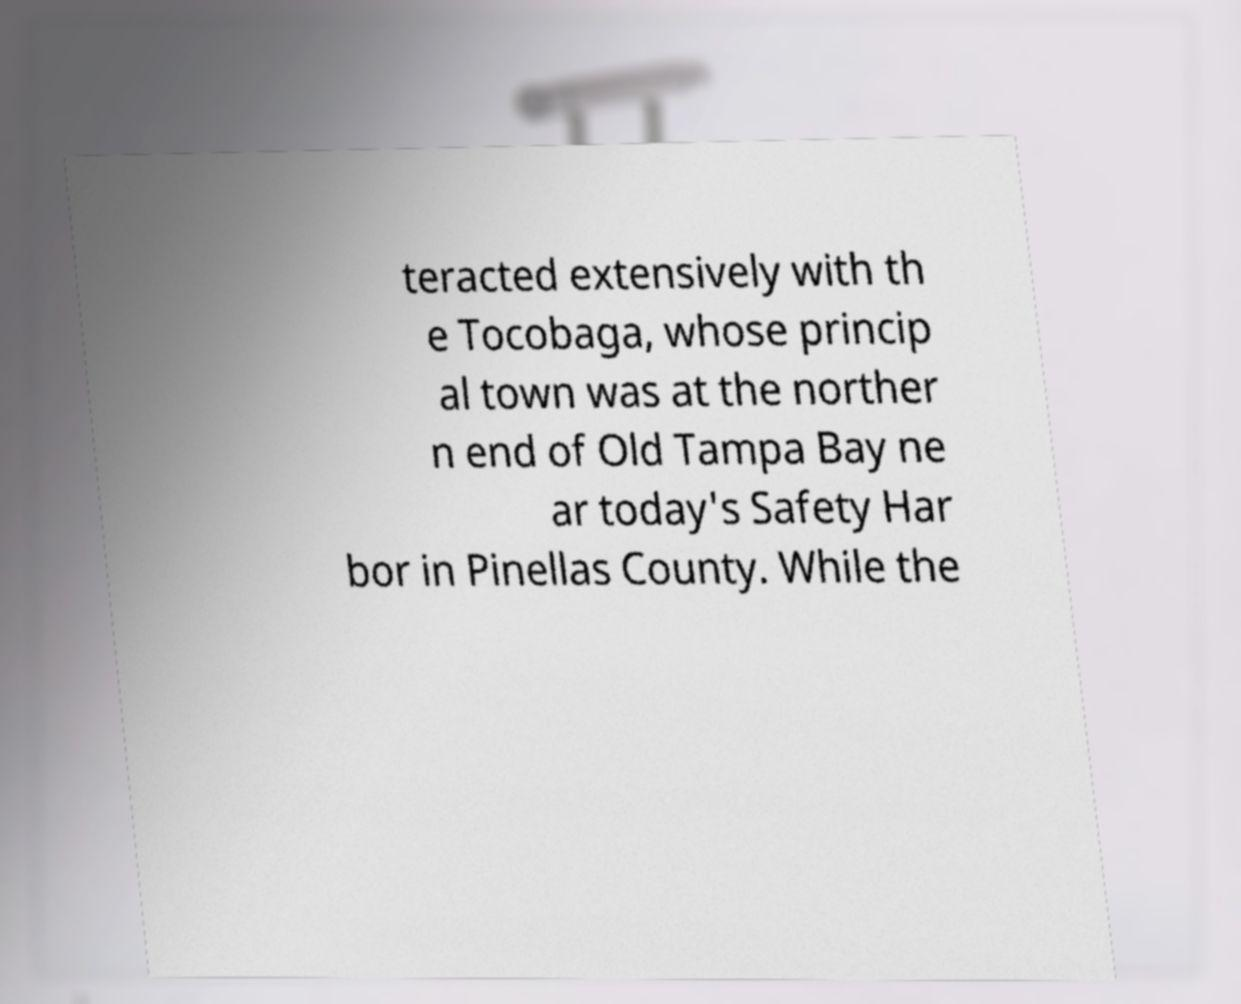Please identify and transcribe the text found in this image. teracted extensively with th e Tocobaga, whose princip al town was at the norther n end of Old Tampa Bay ne ar today's Safety Har bor in Pinellas County. While the 